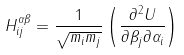<formula> <loc_0><loc_0><loc_500><loc_500>H ^ { \alpha \beta } _ { i j } = \frac { 1 } { \sqrt { m _ { i } m _ { j } } } \left ( \frac { \partial ^ { 2 } U } { \partial \beta _ { j } \partial \alpha _ { i } } \right )</formula> 